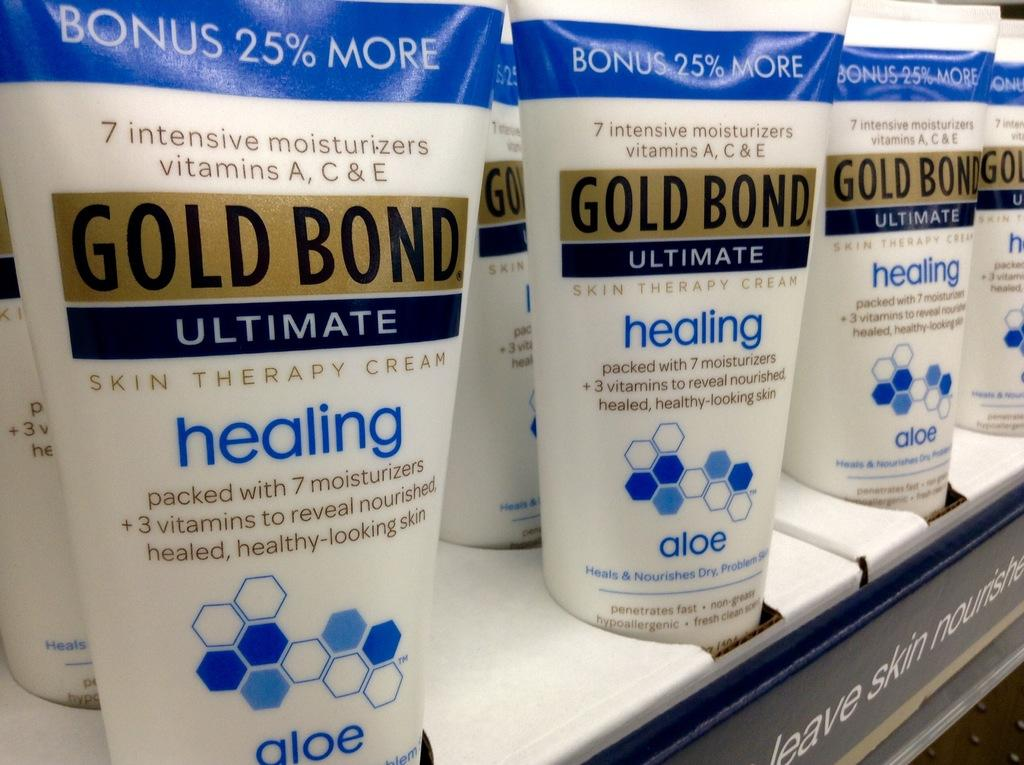<image>
Create a compact narrative representing the image presented. Tubes of Gold Bond ultimate healing aloe are standing next to each other. 